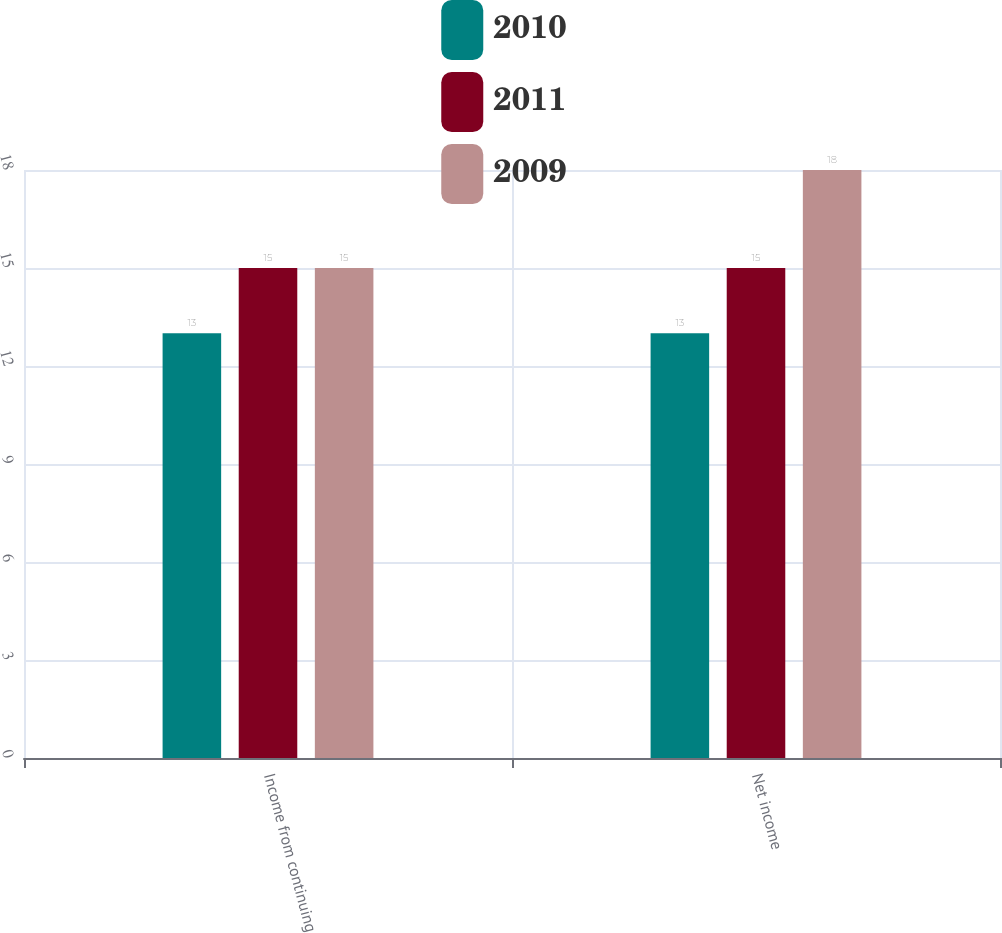Convert chart. <chart><loc_0><loc_0><loc_500><loc_500><stacked_bar_chart><ecel><fcel>Income from continuing<fcel>Net income<nl><fcel>2010<fcel>13<fcel>13<nl><fcel>2011<fcel>15<fcel>15<nl><fcel>2009<fcel>15<fcel>18<nl></chart> 